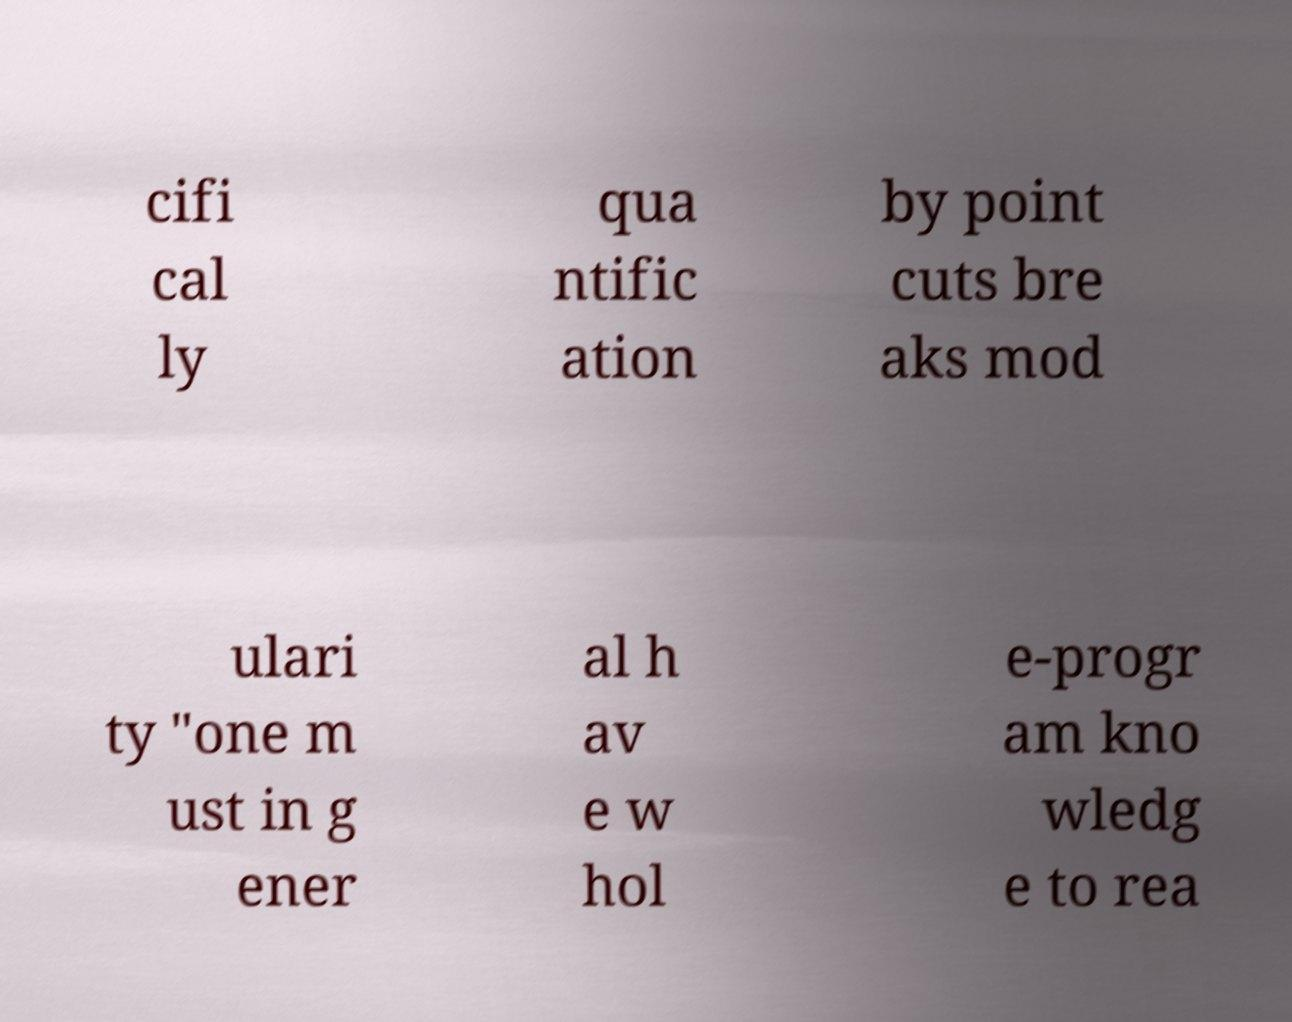Please identify and transcribe the text found in this image. cifi cal ly qua ntific ation by point cuts bre aks mod ulari ty "one m ust in g ener al h av e w hol e-progr am kno wledg e to rea 